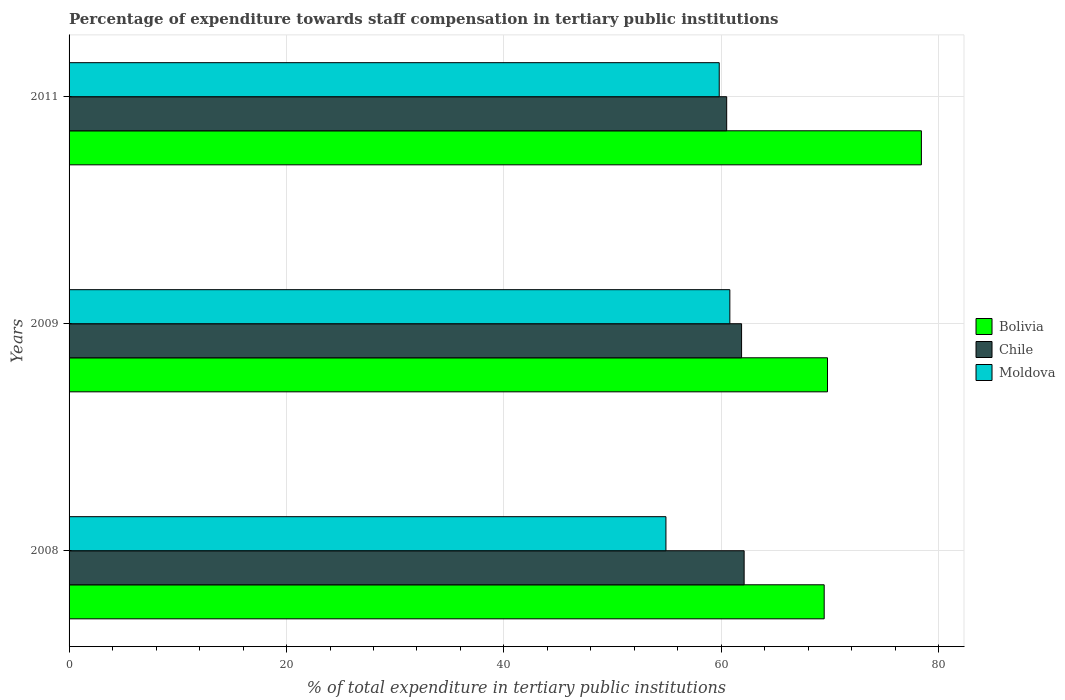How many different coloured bars are there?
Offer a very short reply. 3. Are the number of bars on each tick of the Y-axis equal?
Your answer should be compact. Yes. How many bars are there on the 1st tick from the top?
Your answer should be very brief. 3. How many bars are there on the 2nd tick from the bottom?
Offer a terse response. 3. In how many cases, is the number of bars for a given year not equal to the number of legend labels?
Your answer should be compact. 0. What is the percentage of expenditure towards staff compensation in Chile in 2008?
Provide a succinct answer. 62.09. Across all years, what is the maximum percentage of expenditure towards staff compensation in Chile?
Your response must be concise. 62.09. Across all years, what is the minimum percentage of expenditure towards staff compensation in Bolivia?
Your answer should be compact. 69.46. In which year was the percentage of expenditure towards staff compensation in Bolivia minimum?
Your response must be concise. 2008. What is the total percentage of expenditure towards staff compensation in Moldova in the graph?
Ensure brevity in your answer.  175.48. What is the difference between the percentage of expenditure towards staff compensation in Chile in 2008 and that in 2011?
Your answer should be very brief. 1.61. What is the difference between the percentage of expenditure towards staff compensation in Chile in 2009 and the percentage of expenditure towards staff compensation in Bolivia in 2011?
Offer a very short reply. -16.54. What is the average percentage of expenditure towards staff compensation in Moldova per year?
Offer a terse response. 58.49. In the year 2008, what is the difference between the percentage of expenditure towards staff compensation in Bolivia and percentage of expenditure towards staff compensation in Chile?
Your answer should be very brief. 7.36. What is the ratio of the percentage of expenditure towards staff compensation in Bolivia in 2008 to that in 2009?
Give a very brief answer. 1. What is the difference between the highest and the second highest percentage of expenditure towards staff compensation in Bolivia?
Provide a succinct answer. 8.64. What is the difference between the highest and the lowest percentage of expenditure towards staff compensation in Moldova?
Make the answer very short. 5.88. In how many years, is the percentage of expenditure towards staff compensation in Bolivia greater than the average percentage of expenditure towards staff compensation in Bolivia taken over all years?
Provide a short and direct response. 1. What does the 3rd bar from the top in 2008 represents?
Your answer should be compact. Bolivia. What does the 2nd bar from the bottom in 2011 represents?
Provide a succinct answer. Chile. How many bars are there?
Make the answer very short. 9. Are the values on the major ticks of X-axis written in scientific E-notation?
Provide a succinct answer. No. Does the graph contain grids?
Provide a succinct answer. Yes. What is the title of the graph?
Provide a succinct answer. Percentage of expenditure towards staff compensation in tertiary public institutions. Does "Serbia" appear as one of the legend labels in the graph?
Your answer should be very brief. No. What is the label or title of the X-axis?
Provide a succinct answer. % of total expenditure in tertiary public institutions. What is the label or title of the Y-axis?
Your answer should be compact. Years. What is the % of total expenditure in tertiary public institutions in Bolivia in 2008?
Ensure brevity in your answer.  69.46. What is the % of total expenditure in tertiary public institutions of Chile in 2008?
Give a very brief answer. 62.09. What is the % of total expenditure in tertiary public institutions of Moldova in 2008?
Your response must be concise. 54.9. What is the % of total expenditure in tertiary public institutions of Bolivia in 2009?
Ensure brevity in your answer.  69.76. What is the % of total expenditure in tertiary public institutions in Chile in 2009?
Offer a very short reply. 61.86. What is the % of total expenditure in tertiary public institutions in Moldova in 2009?
Your answer should be very brief. 60.78. What is the % of total expenditure in tertiary public institutions in Bolivia in 2011?
Offer a very short reply. 78.4. What is the % of total expenditure in tertiary public institutions of Chile in 2011?
Provide a short and direct response. 60.49. What is the % of total expenditure in tertiary public institutions in Moldova in 2011?
Your response must be concise. 59.8. Across all years, what is the maximum % of total expenditure in tertiary public institutions in Bolivia?
Ensure brevity in your answer.  78.4. Across all years, what is the maximum % of total expenditure in tertiary public institutions in Chile?
Provide a short and direct response. 62.09. Across all years, what is the maximum % of total expenditure in tertiary public institutions of Moldova?
Your answer should be compact. 60.78. Across all years, what is the minimum % of total expenditure in tertiary public institutions of Bolivia?
Ensure brevity in your answer.  69.46. Across all years, what is the minimum % of total expenditure in tertiary public institutions in Chile?
Make the answer very short. 60.49. Across all years, what is the minimum % of total expenditure in tertiary public institutions in Moldova?
Your response must be concise. 54.9. What is the total % of total expenditure in tertiary public institutions of Bolivia in the graph?
Your answer should be very brief. 217.61. What is the total % of total expenditure in tertiary public institutions in Chile in the graph?
Keep it short and to the point. 184.44. What is the total % of total expenditure in tertiary public institutions of Moldova in the graph?
Your response must be concise. 175.48. What is the difference between the % of total expenditure in tertiary public institutions in Bolivia in 2008 and that in 2009?
Offer a very short reply. -0.3. What is the difference between the % of total expenditure in tertiary public institutions of Chile in 2008 and that in 2009?
Offer a very short reply. 0.24. What is the difference between the % of total expenditure in tertiary public institutions of Moldova in 2008 and that in 2009?
Offer a terse response. -5.88. What is the difference between the % of total expenditure in tertiary public institutions in Bolivia in 2008 and that in 2011?
Your answer should be compact. -8.94. What is the difference between the % of total expenditure in tertiary public institutions in Chile in 2008 and that in 2011?
Offer a terse response. 1.6. What is the difference between the % of total expenditure in tertiary public institutions of Moldova in 2008 and that in 2011?
Offer a very short reply. -4.9. What is the difference between the % of total expenditure in tertiary public institutions of Bolivia in 2009 and that in 2011?
Provide a succinct answer. -8.64. What is the difference between the % of total expenditure in tertiary public institutions in Chile in 2009 and that in 2011?
Make the answer very short. 1.37. What is the difference between the % of total expenditure in tertiary public institutions in Moldova in 2009 and that in 2011?
Make the answer very short. 0.98. What is the difference between the % of total expenditure in tertiary public institutions in Bolivia in 2008 and the % of total expenditure in tertiary public institutions in Chile in 2009?
Provide a succinct answer. 7.6. What is the difference between the % of total expenditure in tertiary public institutions in Bolivia in 2008 and the % of total expenditure in tertiary public institutions in Moldova in 2009?
Your answer should be very brief. 8.68. What is the difference between the % of total expenditure in tertiary public institutions of Chile in 2008 and the % of total expenditure in tertiary public institutions of Moldova in 2009?
Offer a terse response. 1.32. What is the difference between the % of total expenditure in tertiary public institutions in Bolivia in 2008 and the % of total expenditure in tertiary public institutions in Chile in 2011?
Your answer should be compact. 8.97. What is the difference between the % of total expenditure in tertiary public institutions in Bolivia in 2008 and the % of total expenditure in tertiary public institutions in Moldova in 2011?
Give a very brief answer. 9.65. What is the difference between the % of total expenditure in tertiary public institutions of Chile in 2008 and the % of total expenditure in tertiary public institutions of Moldova in 2011?
Offer a terse response. 2.29. What is the difference between the % of total expenditure in tertiary public institutions of Bolivia in 2009 and the % of total expenditure in tertiary public institutions of Chile in 2011?
Offer a very short reply. 9.27. What is the difference between the % of total expenditure in tertiary public institutions of Bolivia in 2009 and the % of total expenditure in tertiary public institutions of Moldova in 2011?
Make the answer very short. 9.96. What is the difference between the % of total expenditure in tertiary public institutions of Chile in 2009 and the % of total expenditure in tertiary public institutions of Moldova in 2011?
Keep it short and to the point. 2.06. What is the average % of total expenditure in tertiary public institutions of Bolivia per year?
Give a very brief answer. 72.54. What is the average % of total expenditure in tertiary public institutions of Chile per year?
Keep it short and to the point. 61.48. What is the average % of total expenditure in tertiary public institutions of Moldova per year?
Ensure brevity in your answer.  58.49. In the year 2008, what is the difference between the % of total expenditure in tertiary public institutions in Bolivia and % of total expenditure in tertiary public institutions in Chile?
Keep it short and to the point. 7.36. In the year 2008, what is the difference between the % of total expenditure in tertiary public institutions in Bolivia and % of total expenditure in tertiary public institutions in Moldova?
Ensure brevity in your answer.  14.56. In the year 2008, what is the difference between the % of total expenditure in tertiary public institutions in Chile and % of total expenditure in tertiary public institutions in Moldova?
Make the answer very short. 7.19. In the year 2009, what is the difference between the % of total expenditure in tertiary public institutions in Bolivia and % of total expenditure in tertiary public institutions in Chile?
Provide a short and direct response. 7.9. In the year 2009, what is the difference between the % of total expenditure in tertiary public institutions of Bolivia and % of total expenditure in tertiary public institutions of Moldova?
Offer a terse response. 8.98. In the year 2009, what is the difference between the % of total expenditure in tertiary public institutions in Chile and % of total expenditure in tertiary public institutions in Moldova?
Keep it short and to the point. 1.08. In the year 2011, what is the difference between the % of total expenditure in tertiary public institutions of Bolivia and % of total expenditure in tertiary public institutions of Chile?
Provide a succinct answer. 17.91. In the year 2011, what is the difference between the % of total expenditure in tertiary public institutions of Bolivia and % of total expenditure in tertiary public institutions of Moldova?
Keep it short and to the point. 18.59. In the year 2011, what is the difference between the % of total expenditure in tertiary public institutions of Chile and % of total expenditure in tertiary public institutions of Moldova?
Ensure brevity in your answer.  0.69. What is the ratio of the % of total expenditure in tertiary public institutions in Moldova in 2008 to that in 2009?
Offer a very short reply. 0.9. What is the ratio of the % of total expenditure in tertiary public institutions in Bolivia in 2008 to that in 2011?
Your response must be concise. 0.89. What is the ratio of the % of total expenditure in tertiary public institutions of Chile in 2008 to that in 2011?
Your answer should be very brief. 1.03. What is the ratio of the % of total expenditure in tertiary public institutions of Moldova in 2008 to that in 2011?
Your response must be concise. 0.92. What is the ratio of the % of total expenditure in tertiary public institutions of Bolivia in 2009 to that in 2011?
Offer a terse response. 0.89. What is the ratio of the % of total expenditure in tertiary public institutions in Chile in 2009 to that in 2011?
Offer a terse response. 1.02. What is the ratio of the % of total expenditure in tertiary public institutions in Moldova in 2009 to that in 2011?
Ensure brevity in your answer.  1.02. What is the difference between the highest and the second highest % of total expenditure in tertiary public institutions of Bolivia?
Your answer should be very brief. 8.64. What is the difference between the highest and the second highest % of total expenditure in tertiary public institutions of Chile?
Your response must be concise. 0.24. What is the difference between the highest and the second highest % of total expenditure in tertiary public institutions of Moldova?
Offer a very short reply. 0.98. What is the difference between the highest and the lowest % of total expenditure in tertiary public institutions in Bolivia?
Provide a short and direct response. 8.94. What is the difference between the highest and the lowest % of total expenditure in tertiary public institutions of Chile?
Make the answer very short. 1.6. What is the difference between the highest and the lowest % of total expenditure in tertiary public institutions of Moldova?
Make the answer very short. 5.88. 